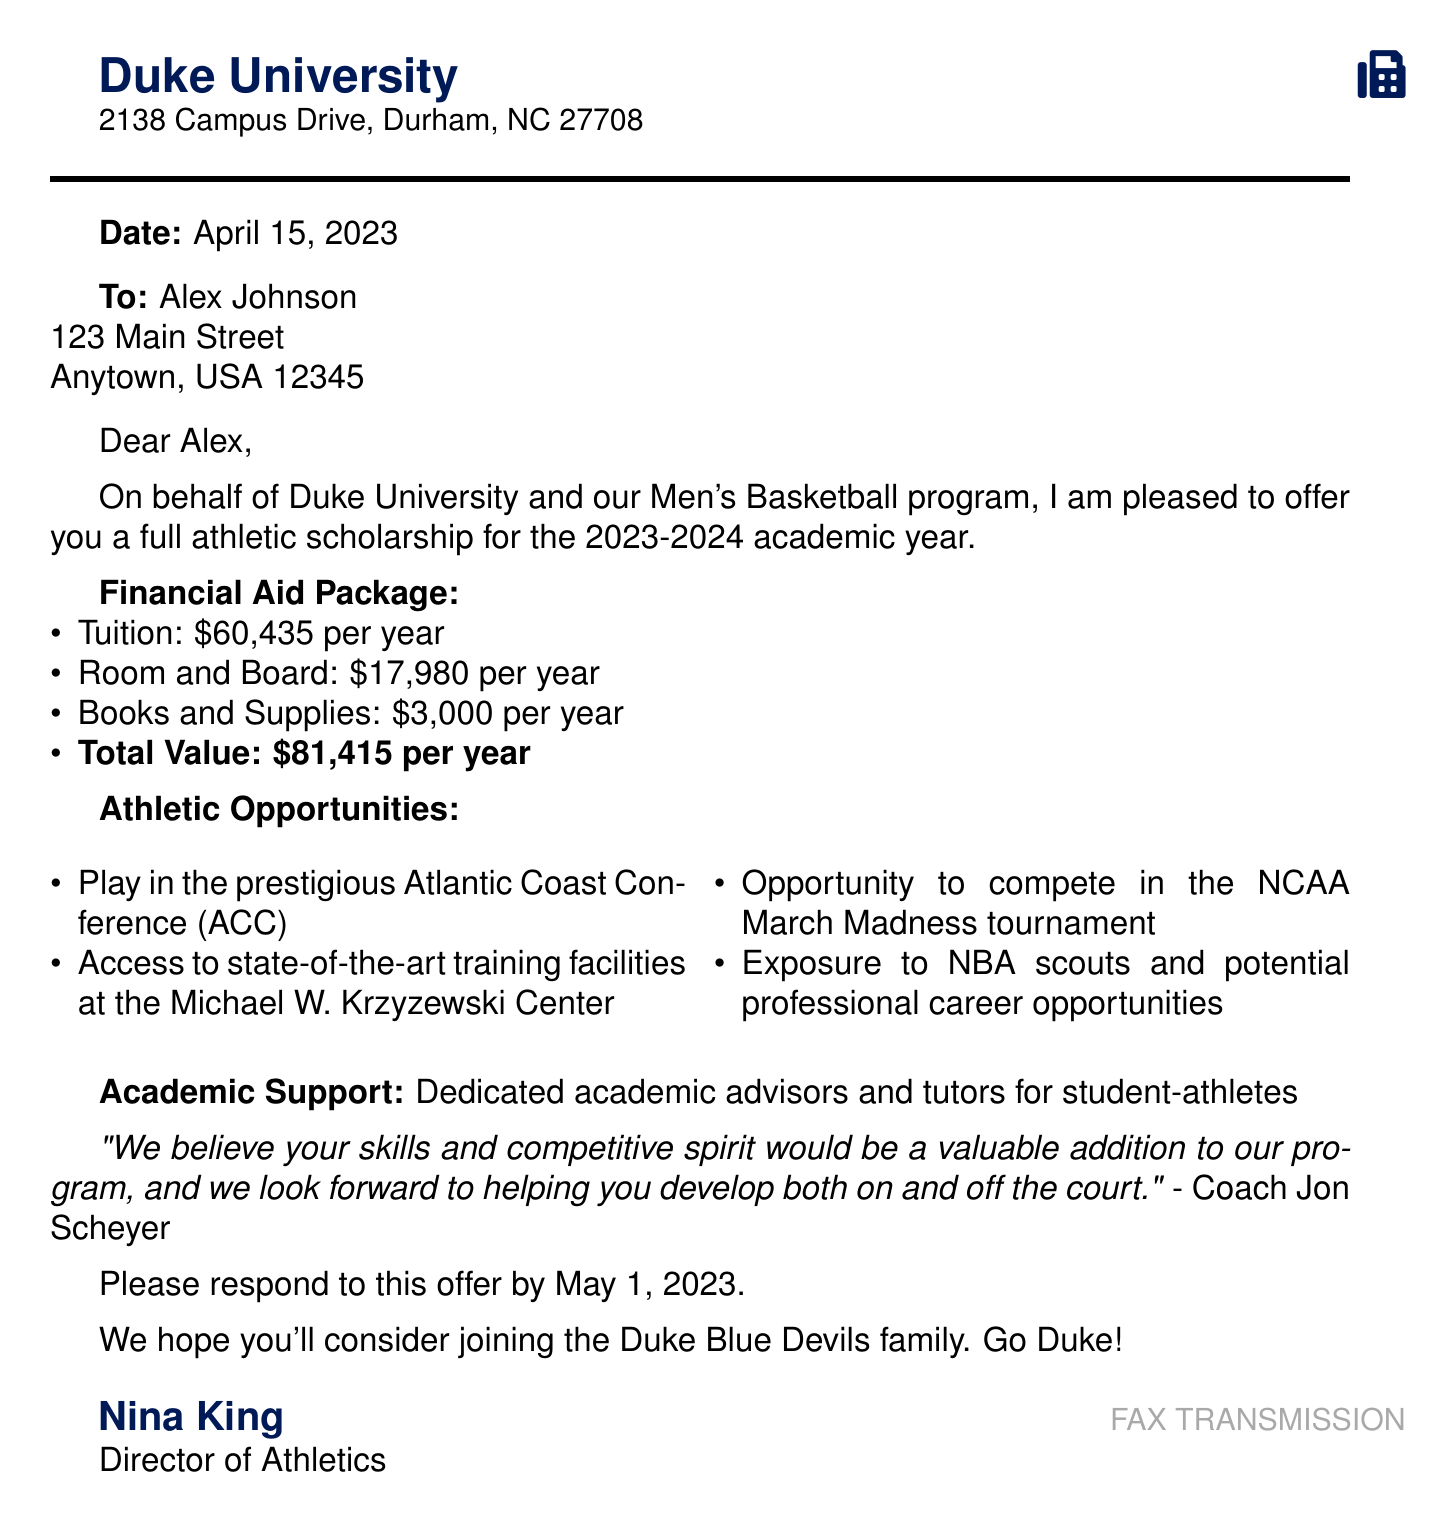What is the total value of the scholarship per year? The total value of the scholarship is provided in the financial aid package section of the document.
Answer: $81,415 Who is the Director of Athletics? The document states the Director of Athletics at Duke University.
Answer: Nina King What is the scholarship offer due date? The document specifies a date by which to respond to the scholarship offer.
Answer: May 1, 2023 What is the name of the basketball conference mentioned? The conference in which the team competes is mentioned in the athletic opportunities section.
Answer: Atlantic Coast Conference (ACC) What opportunities does the basketball program offer related to NCAA? The document outlines specific athletic opportunities available to scholarship recipients.
Answer: Compete in the NCAA March Madness tournament What amount is designated for books and supplies? This information is found in the financial aid package, listing specific amounts for expenses.
Answer: $3,000 per year Where is Duke University located? The address of Duke University is stated at the beginning of the document.
Answer: 2138 Campus Drive, Durham, NC 27708 Who is the signatory of the offer letter? The end of the letter indicates the individual who signed the letter on behalf of the institution.
Answer: Coach Jon Scheyer 